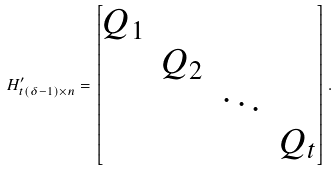<formula> <loc_0><loc_0><loc_500><loc_500>H ^ { \prime } _ { t ( \delta - 1 ) \times n } = \begin{bmatrix} Q _ { 1 } & & & \\ & Q _ { 2 } & & \\ & & \ddots & \\ & & & Q _ { t } \\ \end{bmatrix} .</formula> 